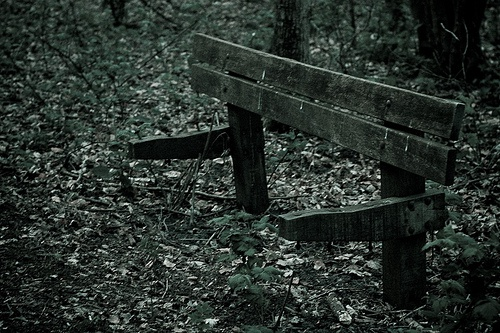Describe the objects in this image and their specific colors. I can see a bench in black, gray, and darkgray tones in this image. 